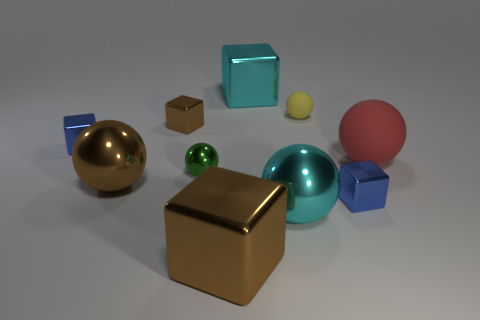There is a red rubber thing to the right of the yellow rubber object; is it the same size as the big cyan sphere?
Provide a succinct answer. Yes. How many other large things have the same material as the green thing?
Your answer should be compact. 4. What number of objects are large blue rubber cubes or brown shiny blocks?
Your response must be concise. 2. Are there any tiny yellow metal things?
Your answer should be very brief. No. What is the material of the large cyan object that is in front of the blue cube to the left of the cyan metallic thing that is in front of the big red sphere?
Keep it short and to the point. Metal. Are there fewer big red matte objects in front of the large brown metallic block than tiny green metallic spheres?
Keep it short and to the point. Yes. What material is the sphere that is the same size as the yellow matte thing?
Give a very brief answer. Metal. How big is the shiny thing that is behind the red object and to the right of the tiny green shiny thing?
Your answer should be compact. Large. There is another rubber thing that is the same shape as the small yellow matte thing; what size is it?
Provide a short and direct response. Large. What number of objects are either large brown shiny cylinders or big metallic balls left of the big cyan sphere?
Your response must be concise. 1. 